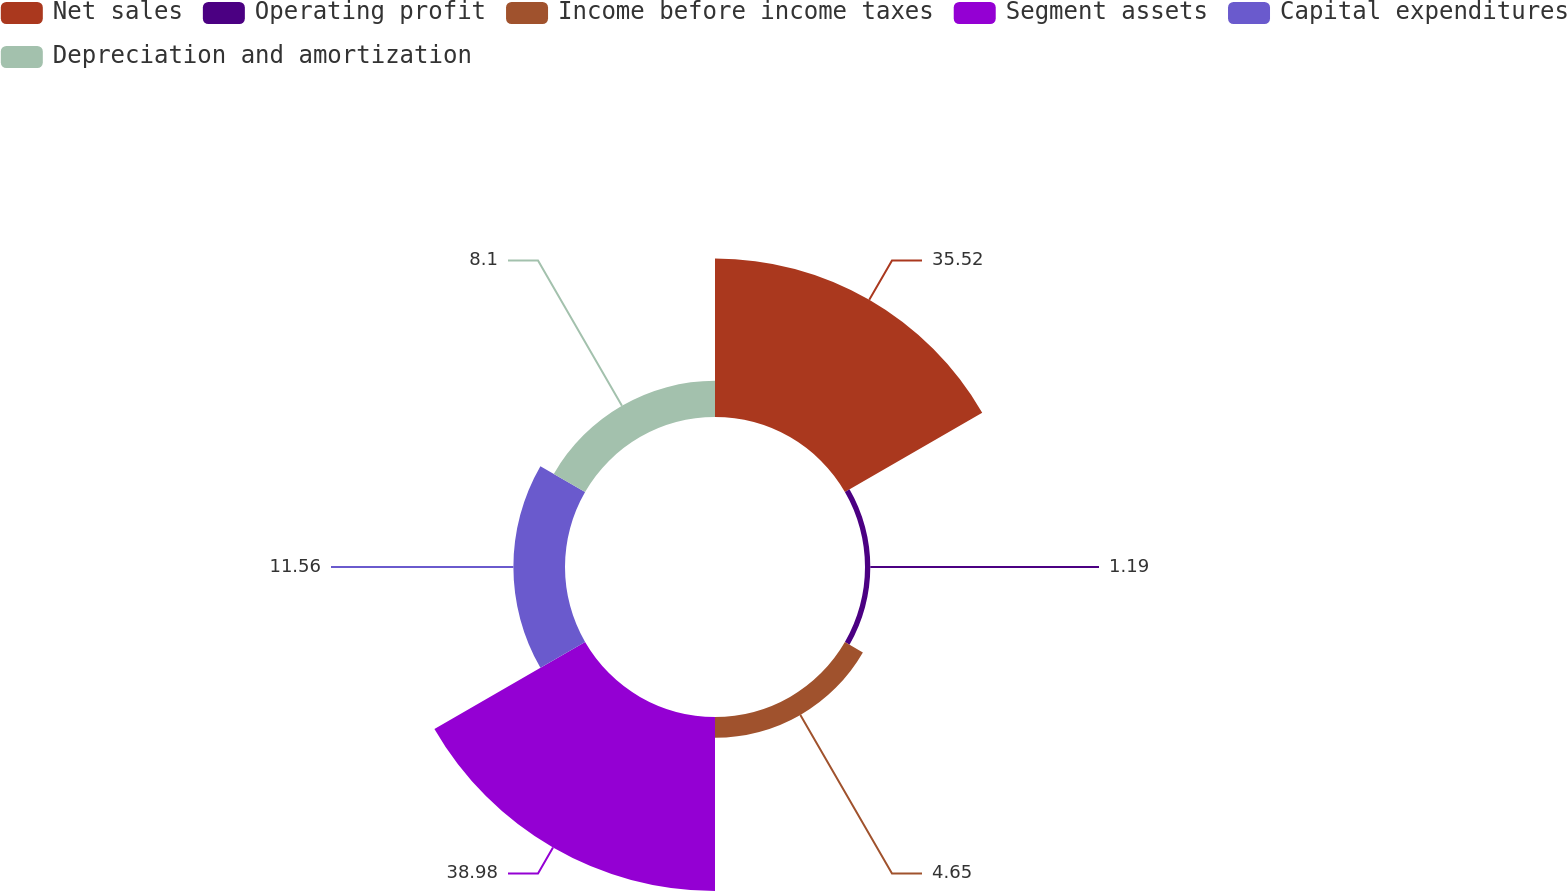Convert chart. <chart><loc_0><loc_0><loc_500><loc_500><pie_chart><fcel>Net sales<fcel>Operating profit<fcel>Income before income taxes<fcel>Segment assets<fcel>Capital expenditures<fcel>Depreciation and amortization<nl><fcel>35.52%<fcel>1.19%<fcel>4.65%<fcel>38.98%<fcel>11.56%<fcel>8.1%<nl></chart> 